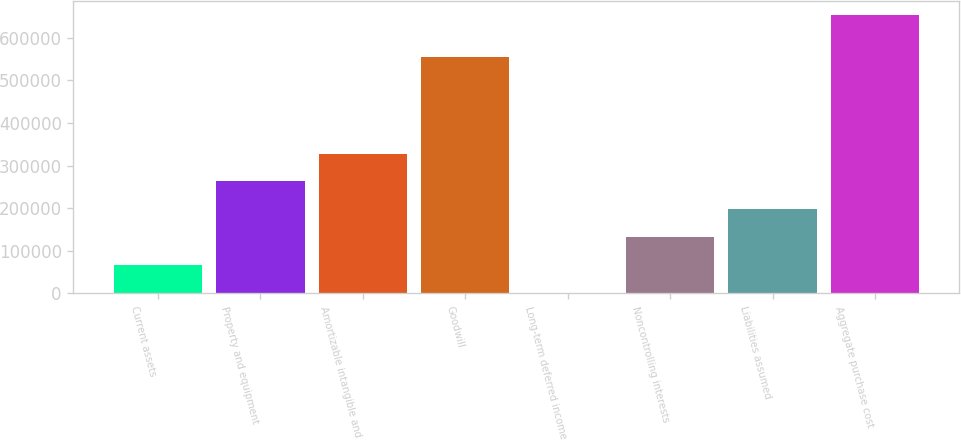Convert chart. <chart><loc_0><loc_0><loc_500><loc_500><bar_chart><fcel>Current assets<fcel>Property and equipment<fcel>Amortizable intangible and<fcel>Goodwill<fcel>Long-term deferred income<fcel>Noncontrolling interests<fcel>Liabilities assumed<fcel>Aggregate purchase cost<nl><fcel>67096.1<fcel>262870<fcel>328128<fcel>554685<fcel>1838<fcel>132354<fcel>197612<fcel>654419<nl></chart> 